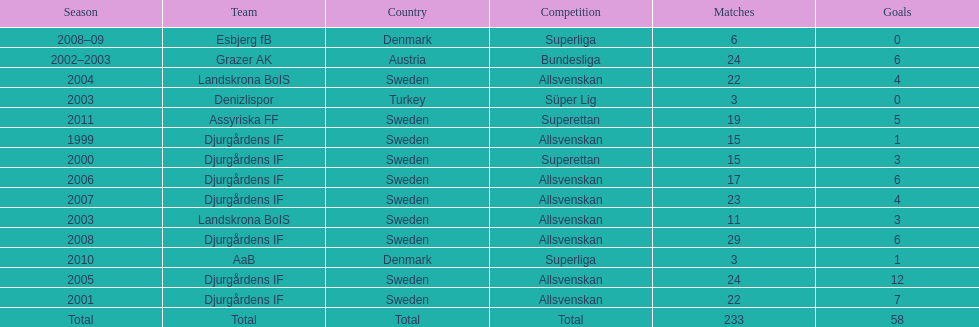How many total goals has jones kusi-asare scored? 58. 